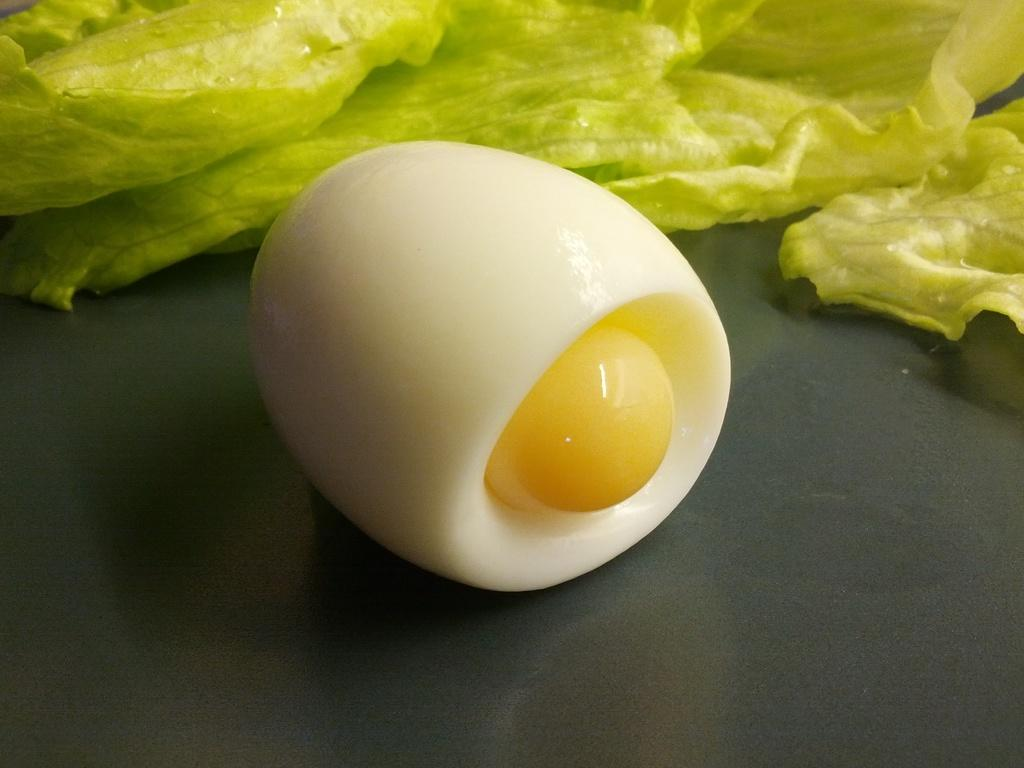What is the main subject of the image? The main subject of the image is an egg. Can you describe the state of the egg? The egg is boiled. What can be seen in the background of the image? There are cabbage leaves in the background of the image. How is the egg positioned in the image? The egg appears to be on a plate at the bottom of the image. What type of hammer is used to make the paste in the image? There is no hammer or paste present in the image; it features a boiled egg and cabbage leaves. 